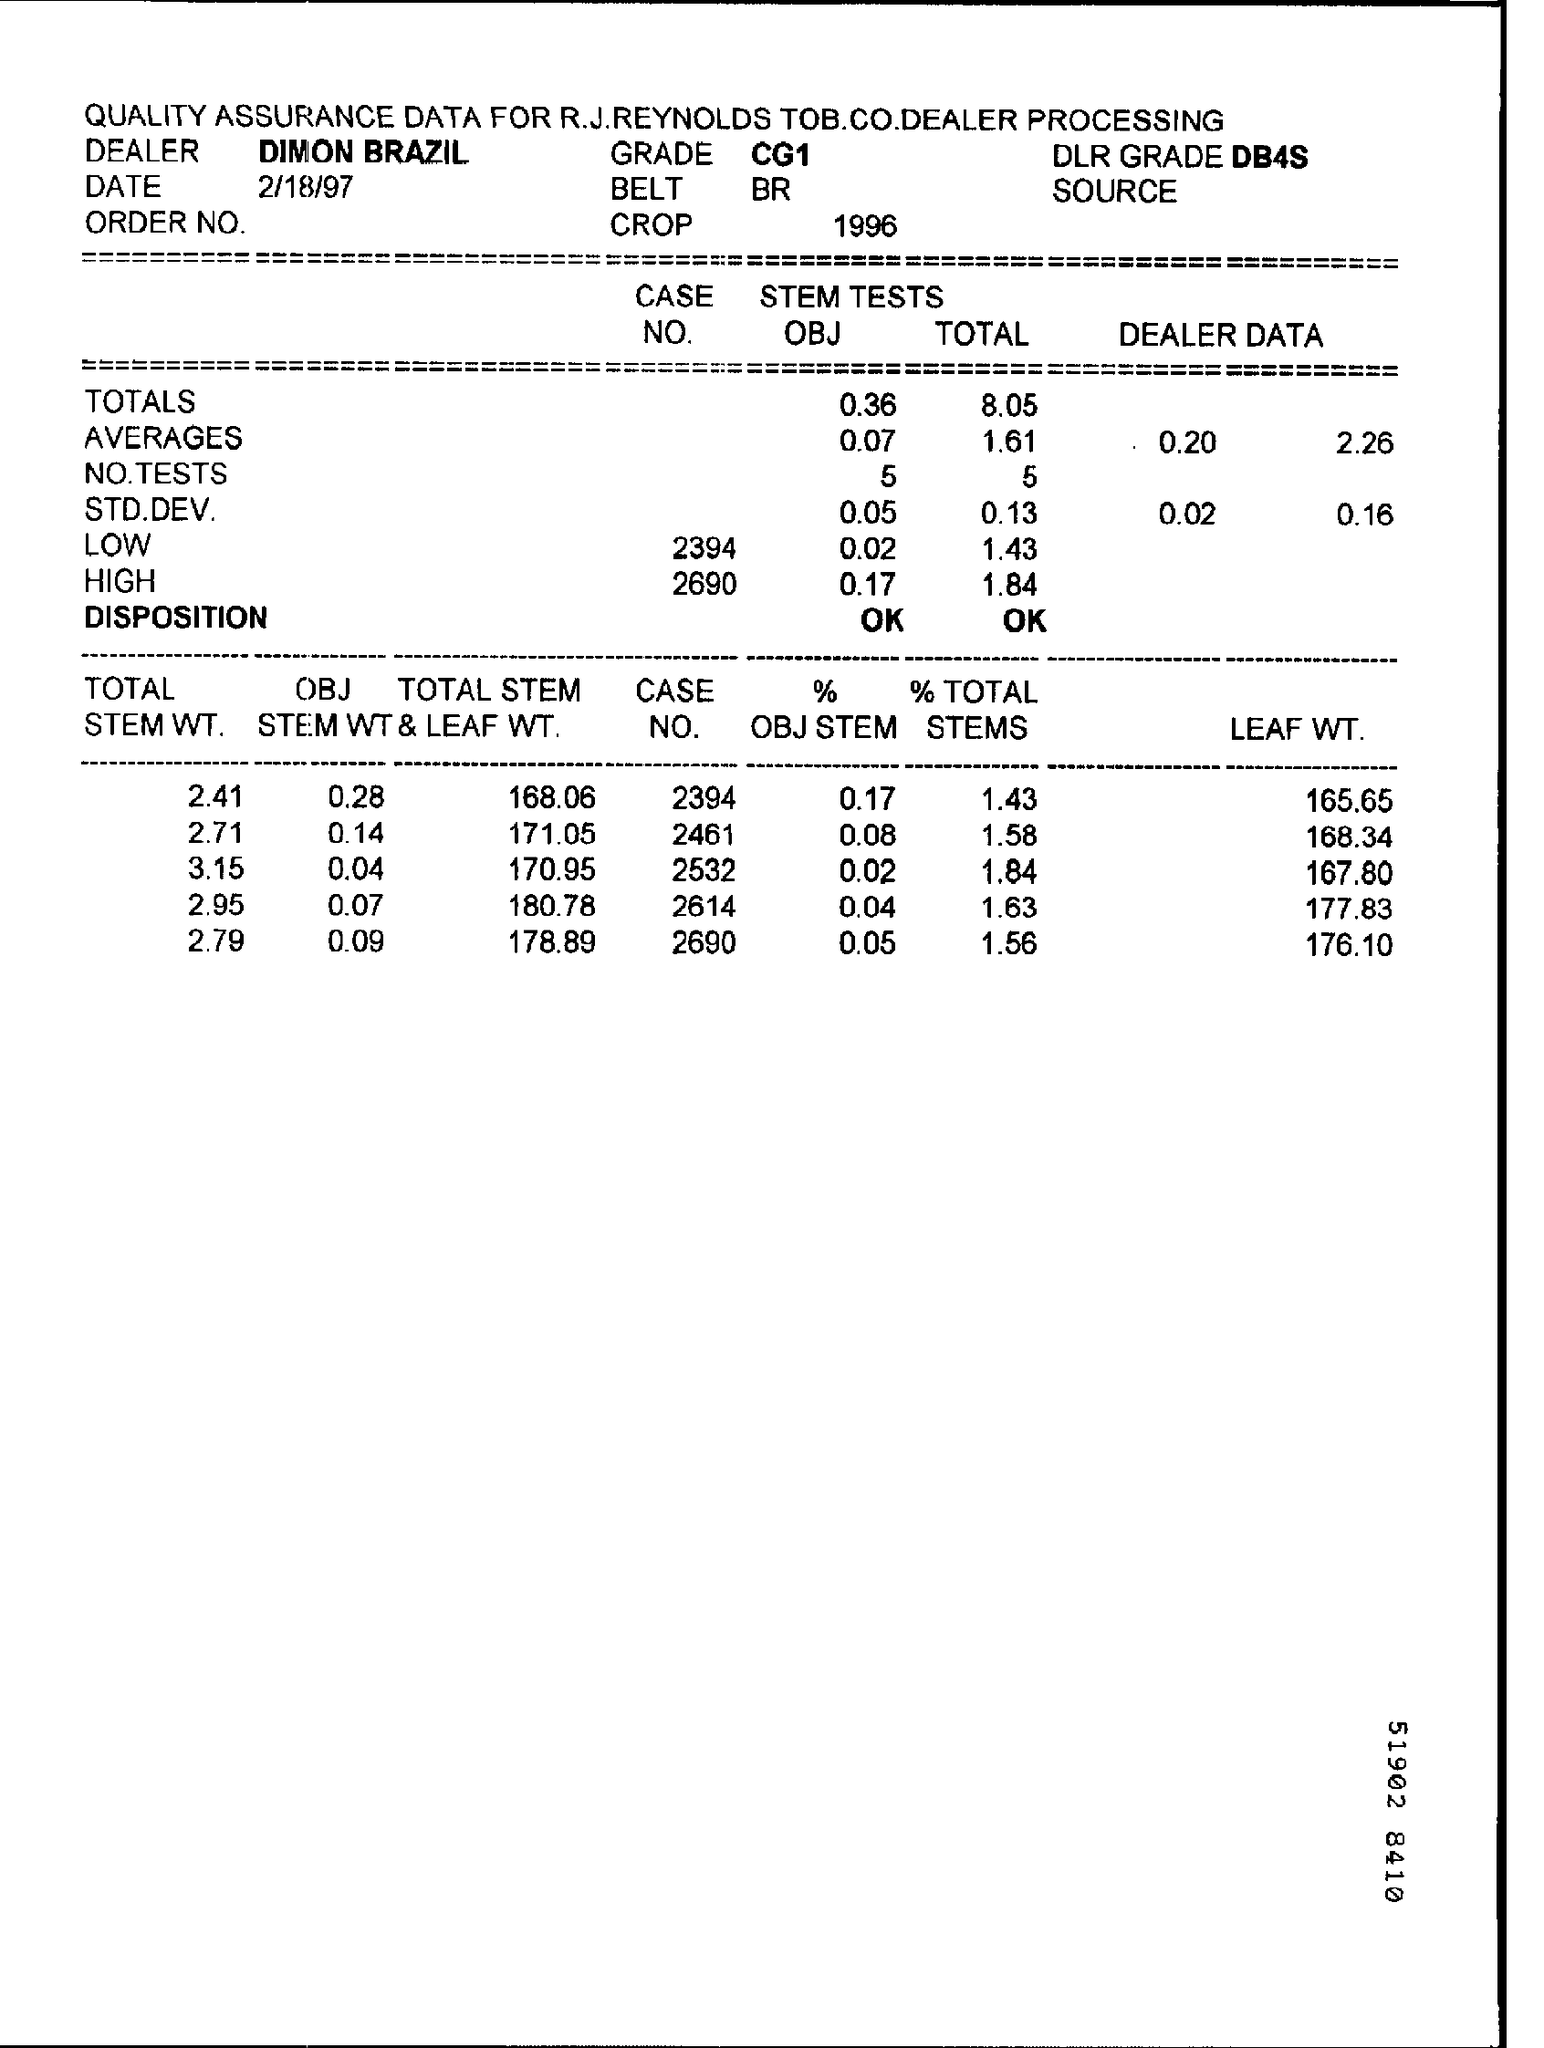What is the Date?
Your answer should be very brief. 2/18/97. What is the Grade?
Make the answer very short. CG1. WHAT IS THE DLR Grade?
Offer a terse response. DB4S. What is the Belt?
Give a very brief answer. BR. What is the Crop?
Keep it short and to the point. 1996. 